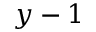Convert formula to latex. <formula><loc_0><loc_0><loc_500><loc_500>y - 1</formula> 